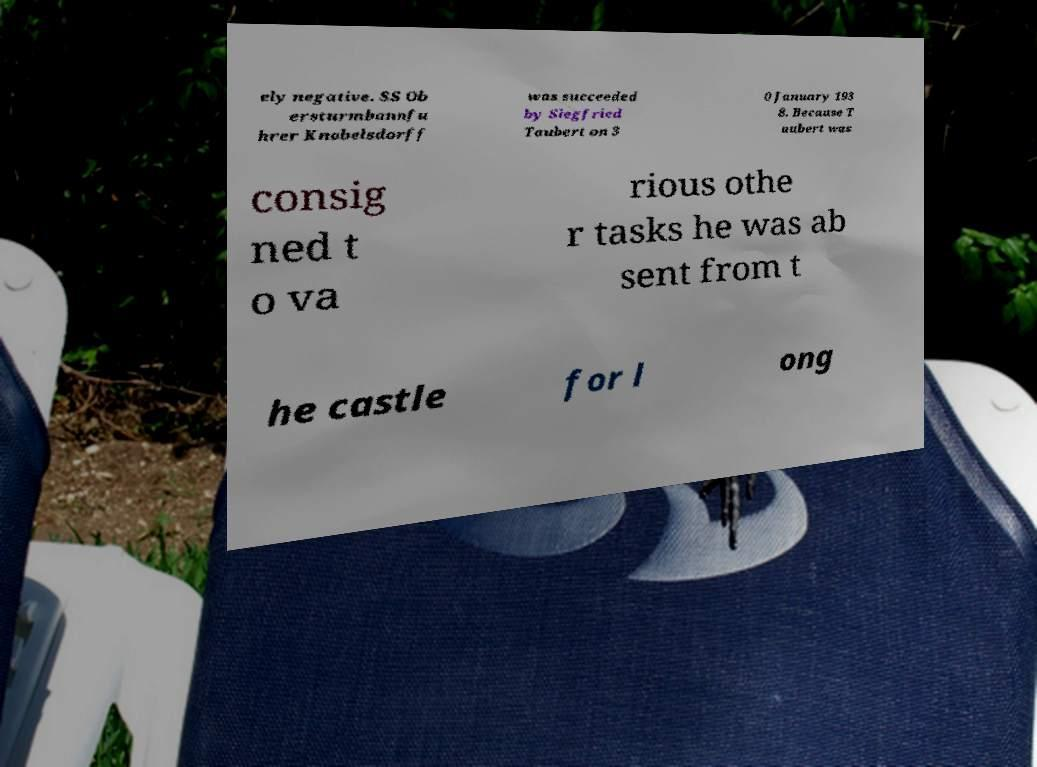For documentation purposes, I need the text within this image transcribed. Could you provide that? ely negative. SS Ob ersturmbannfu hrer Knobelsdorff was succeeded by Siegfried Taubert on 3 0 January 193 8. Because T aubert was consig ned t o va rious othe r tasks he was ab sent from t he castle for l ong 